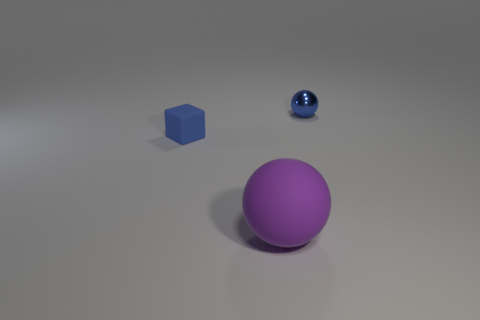Are there fewer large purple objects that are in front of the large matte sphere than large yellow metallic balls?
Your response must be concise. No. Are there any tiny metal things that have the same shape as the small blue rubber object?
Ensure brevity in your answer.  No. There is a rubber thing that is the same size as the blue metal ball; what shape is it?
Provide a short and direct response. Cube. How many things are either metallic cylinders or small blue objects?
Your response must be concise. 2. Is there a metal ball?
Offer a terse response. Yes. Are there fewer tiny blue balls than small purple matte cylinders?
Your answer should be very brief. No. Are there any gray rubber cubes that have the same size as the blue cube?
Provide a succinct answer. No. Is the shape of the large purple object the same as the blue thing that is behind the matte block?
Keep it short and to the point. Yes. How many cylinders are either large objects or tiny matte objects?
Ensure brevity in your answer.  0. The tiny matte cube is what color?
Give a very brief answer. Blue. 